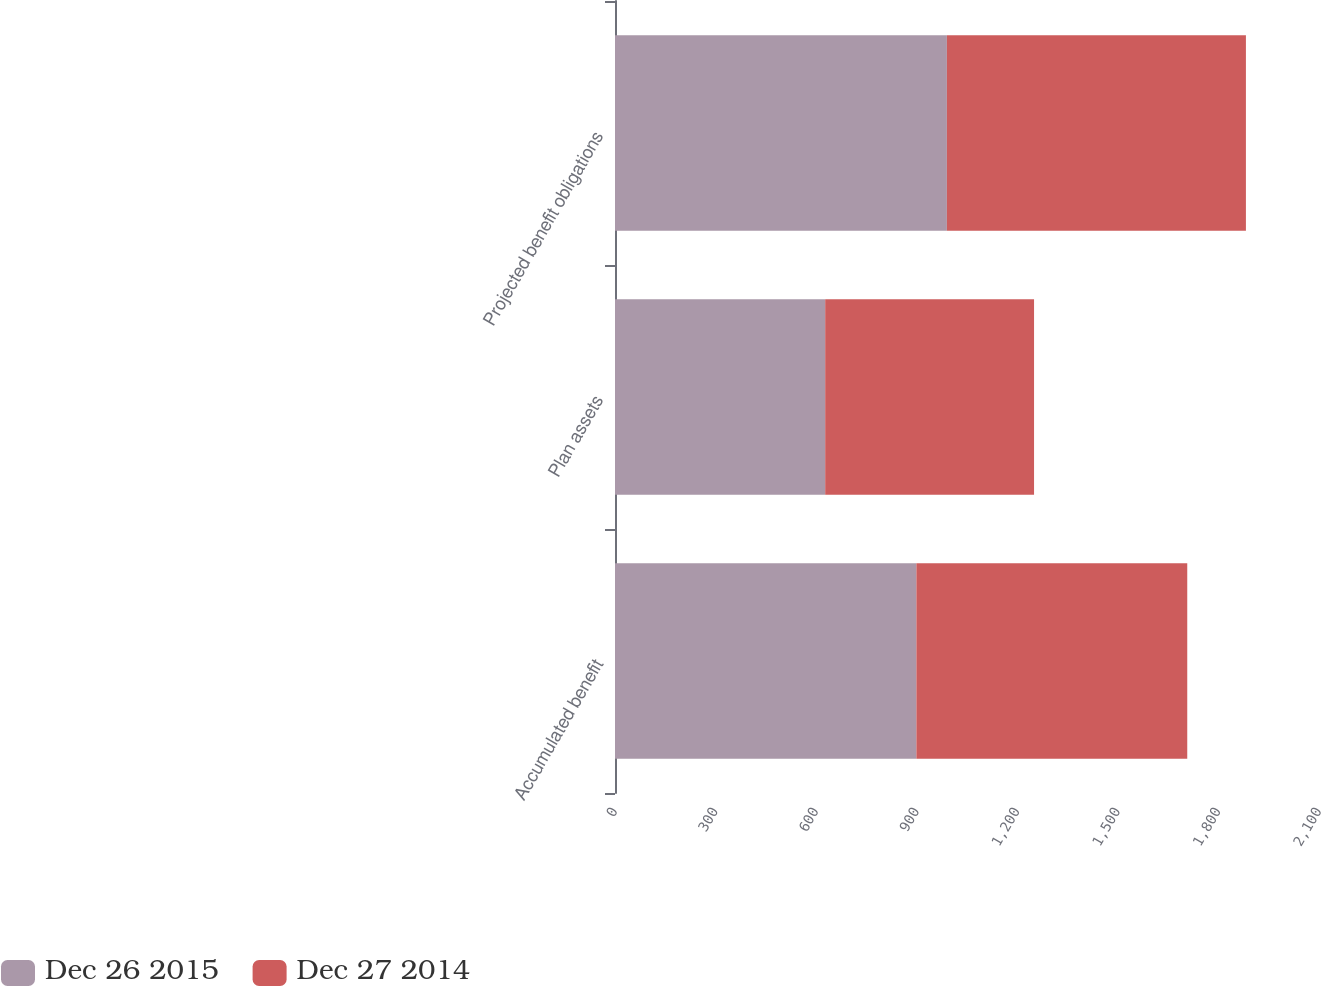<chart> <loc_0><loc_0><loc_500><loc_500><stacked_bar_chart><ecel><fcel>Accumulated benefit<fcel>Plan assets<fcel>Projected benefit obligations<nl><fcel>Dec 26 2015<fcel>899<fcel>627<fcel>990<nl><fcel>Dec 27 2014<fcel>808<fcel>623<fcel>892<nl></chart> 